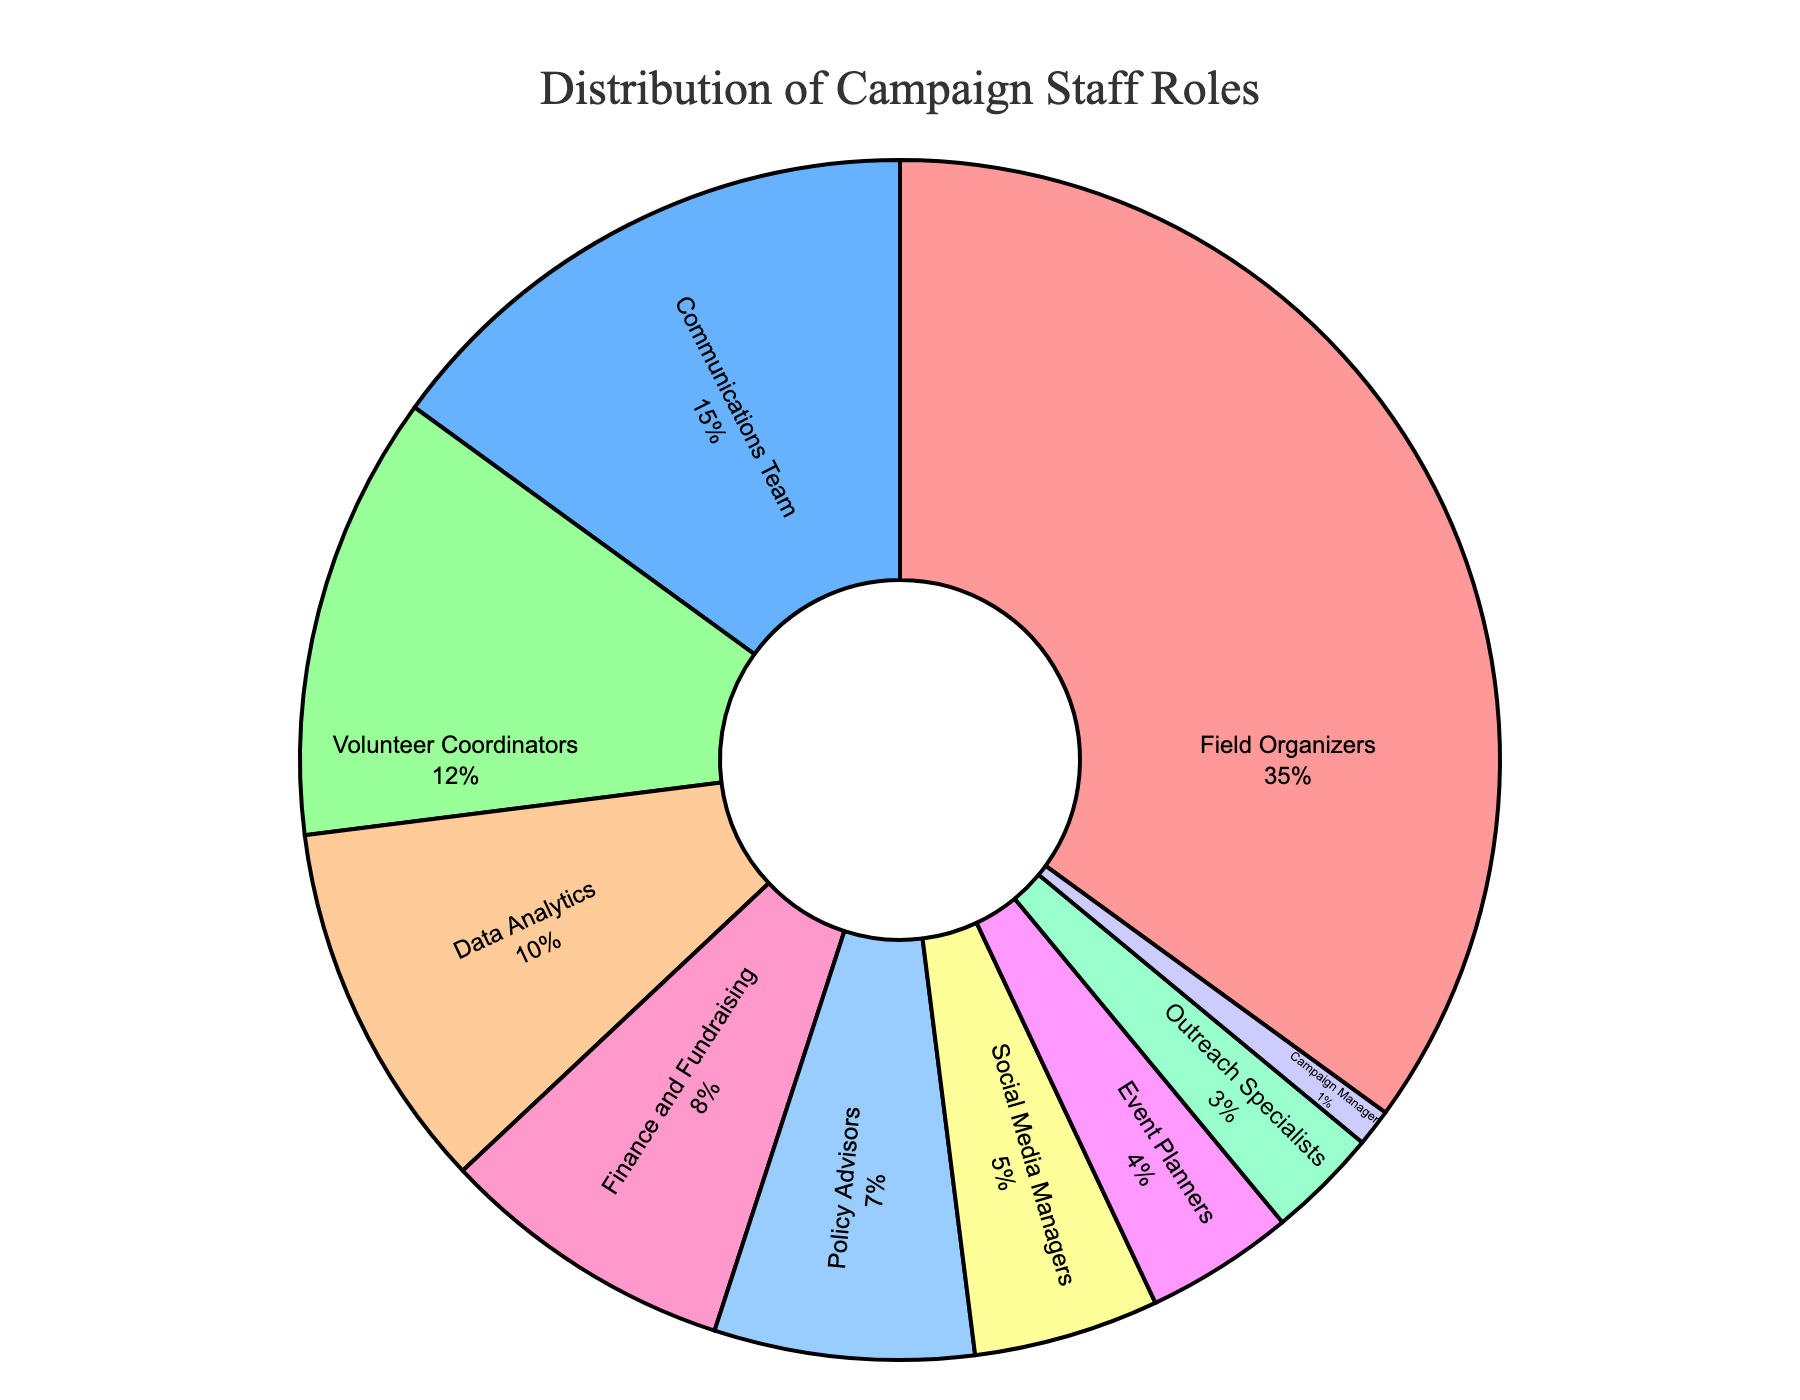What is the largest staff role in the campaign? The largest staff role is represented by the largest segment in the pie, which is the Field Organizers segment.
Answer: Field Organizers Which two staff roles together make up 20 percent of the staff? By examining the pie chart, the Communications Team and Volunteer Coordinators together make up (15% + 12%) = 27%. After reducing to the closest 20%, we see Finance and Fundraising (8%) combined with Outreach Specialists (3%) are closer. Others don't exactly compose to 20%.
Answer: Finance and Fundraising and Outreach Specialists Which staff roles make up less than 10 percent of the campaign staff? From the pie chart, identify segments representing less than 10%. These are Data Analytics (10% is not under 10%), Finance and Fundraising (8%), Policy Advisors (7%), Social Media Managers (5%), Event Planners (4%), Outreach Specialists (3%), and Campaign Manager (1%).
Answer: Finance and Fundraising, Policy Advisors, Social Media Managers, Event Planners, Outreach Specialists, Campaign Manager What is the difference in percentage between the largest and smallest staff roles? The largest role is Field Organizers at 35%, and the smallest is Campaign Manager at 1%. The difference is 35% - 1% = 34%.
Answer: 34% Which staff role has the same color as the segment immediately counterclockwise to the Campaign Manager? The pie chart generates with specific colors, but without the chart, we assume it maintains a standard order, with the Communications Team counterclockwise next to Campaign Manager. So it should share dominant color.
Answer: Communications Team What percentage of the staff is allocated to roles related to team coordination (Field Organizers and Volunteer Coordinators)? Add the percentages for Field Organizers and Volunteer Coordinators, which are 35% and 12% respectively. The total is 35% + 12% = 47%.
Answer: 47% What's the collective percentage of roles associated with outreach (Field Organizers, Volunteer Coordinators, Outreach Specialists)? Summing their percentages, Field Organizers (35%) + Volunteer Coordinators (12%) + Outreach Specialists (3%) = 50%.
Answer: 50% What is 5 percent less than the allocation for Finance and Fundraising? The percentage for Finance and Fundraising is 8%. So, 8% - 5% = 3%.
Answer: 3% Which three staff roles combined constitute over half of the campaign staff? Add percentages of the three largest segments: Field Organizers (35%), Communications Team (15%), and Volunteer Coordinators (12%). Their total is 35% + 15% + 12% = 62%.
Answer: Field Organizers, Communications Team, Volunteer Coordinators 